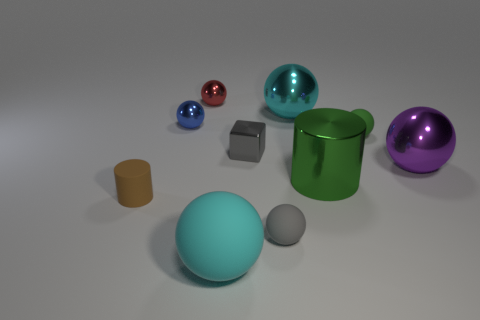What color is the large matte ball?
Offer a very short reply. Cyan. Does the large metallic sphere to the left of the small green matte sphere have the same color as the tiny rubber object that is left of the red object?
Ensure brevity in your answer.  No. There is a blue metal thing that is the same shape as the small green matte object; what is its size?
Your answer should be very brief. Small. Are there any balls of the same color as the tiny metallic block?
Your response must be concise. Yes. What is the material of the tiny sphere that is the same color as the tiny block?
Your response must be concise. Rubber. What number of other big rubber objects have the same color as the big matte thing?
Offer a terse response. 0. What number of things are tiny objects behind the large green cylinder or brown blocks?
Make the answer very short. 4. What is the color of the tiny cube that is made of the same material as the green cylinder?
Offer a terse response. Gray. Is there a gray object that has the same size as the gray sphere?
Give a very brief answer. Yes. What number of things are big metallic things that are to the left of the purple shiny sphere or big spheres that are behind the purple metallic object?
Give a very brief answer. 2. 